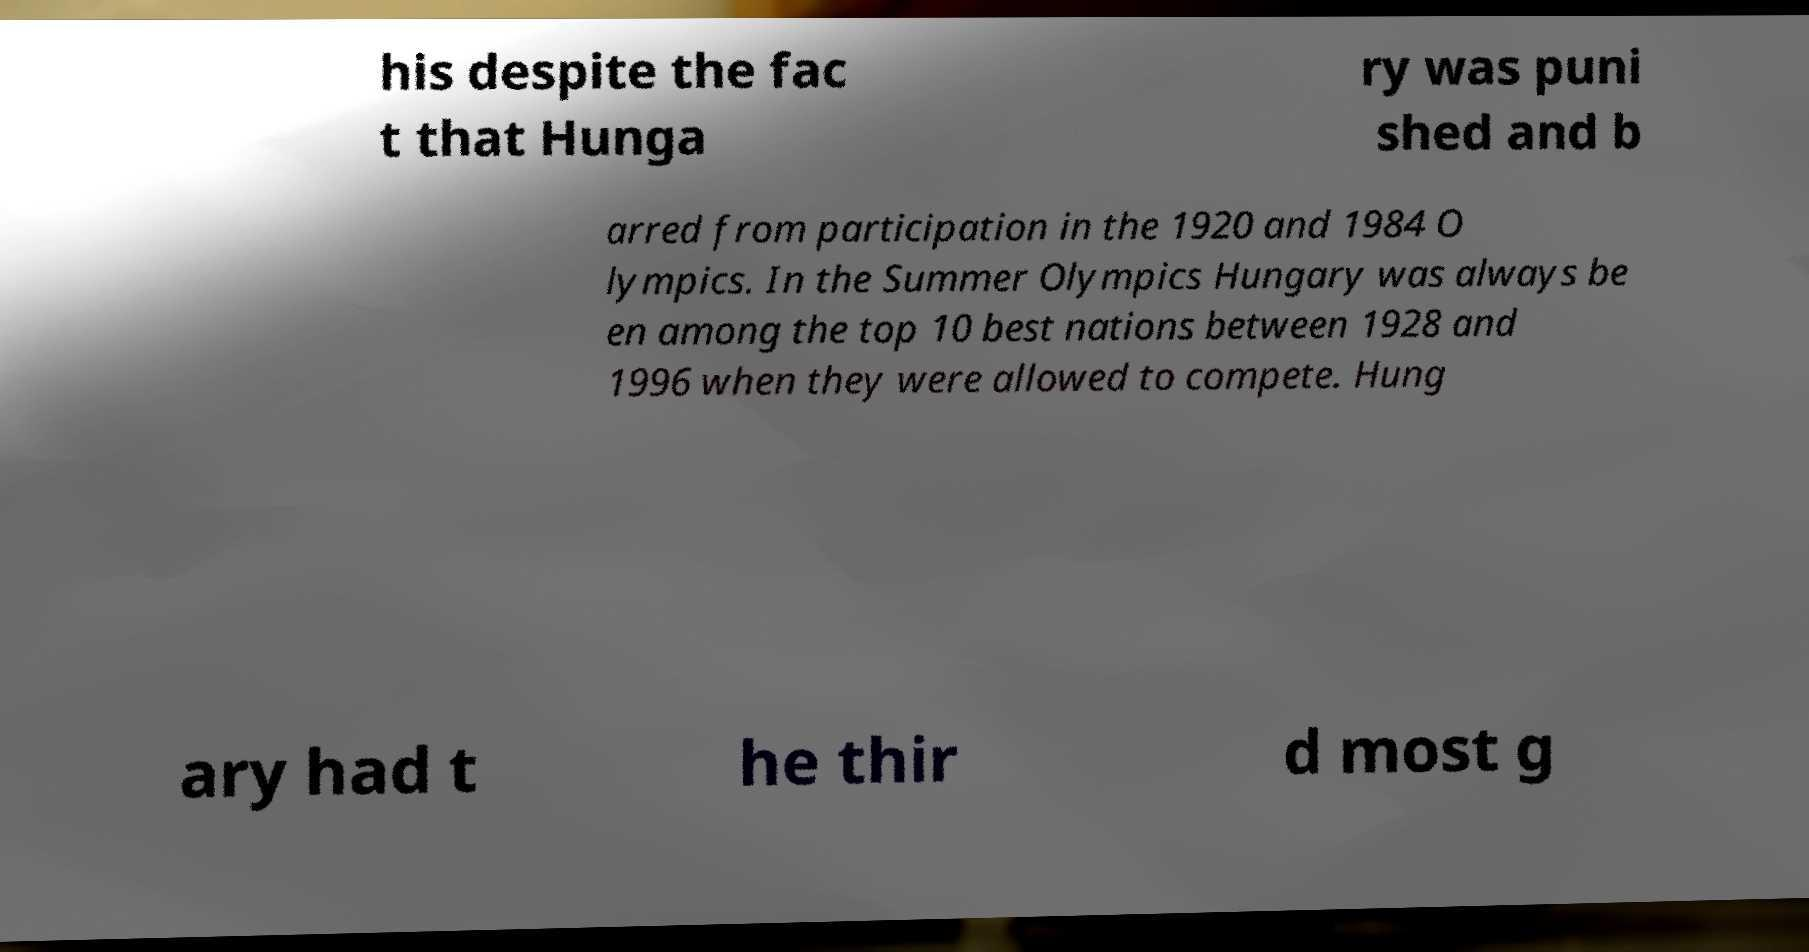Please read and relay the text visible in this image. What does it say? his despite the fac t that Hunga ry was puni shed and b arred from participation in the 1920 and 1984 O lympics. In the Summer Olympics Hungary was always be en among the top 10 best nations between 1928 and 1996 when they were allowed to compete. Hung ary had t he thir d most g 